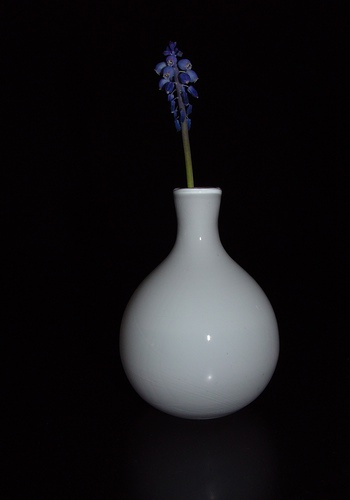Describe the objects in this image and their specific colors. I can see a vase in black, darkgray, and gray tones in this image. 